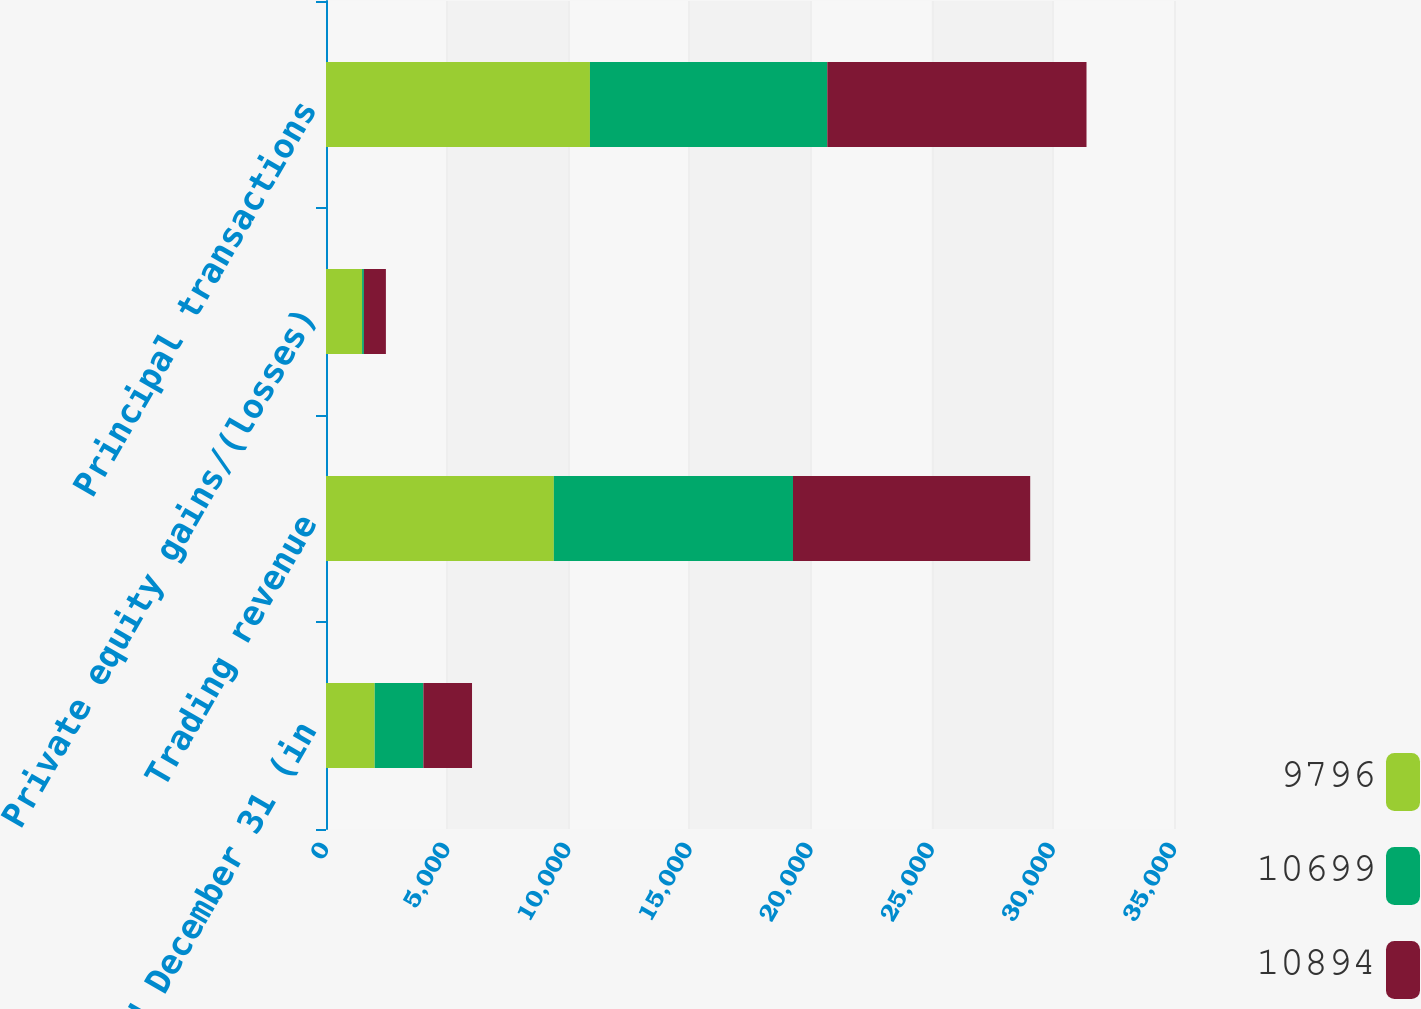Convert chart to OTSL. <chart><loc_0><loc_0><loc_500><loc_500><stacked_bar_chart><ecel><fcel>Year ended December 31 (in<fcel>Trading revenue<fcel>Private equity gains/(losses)<fcel>Principal transactions<nl><fcel>9796<fcel>2010<fcel>9404<fcel>1490<fcel>10894<nl><fcel>10699<fcel>2009<fcel>9870<fcel>74<fcel>9796<nl><fcel>10894<fcel>2008<fcel>9791<fcel>908<fcel>10699<nl></chart> 